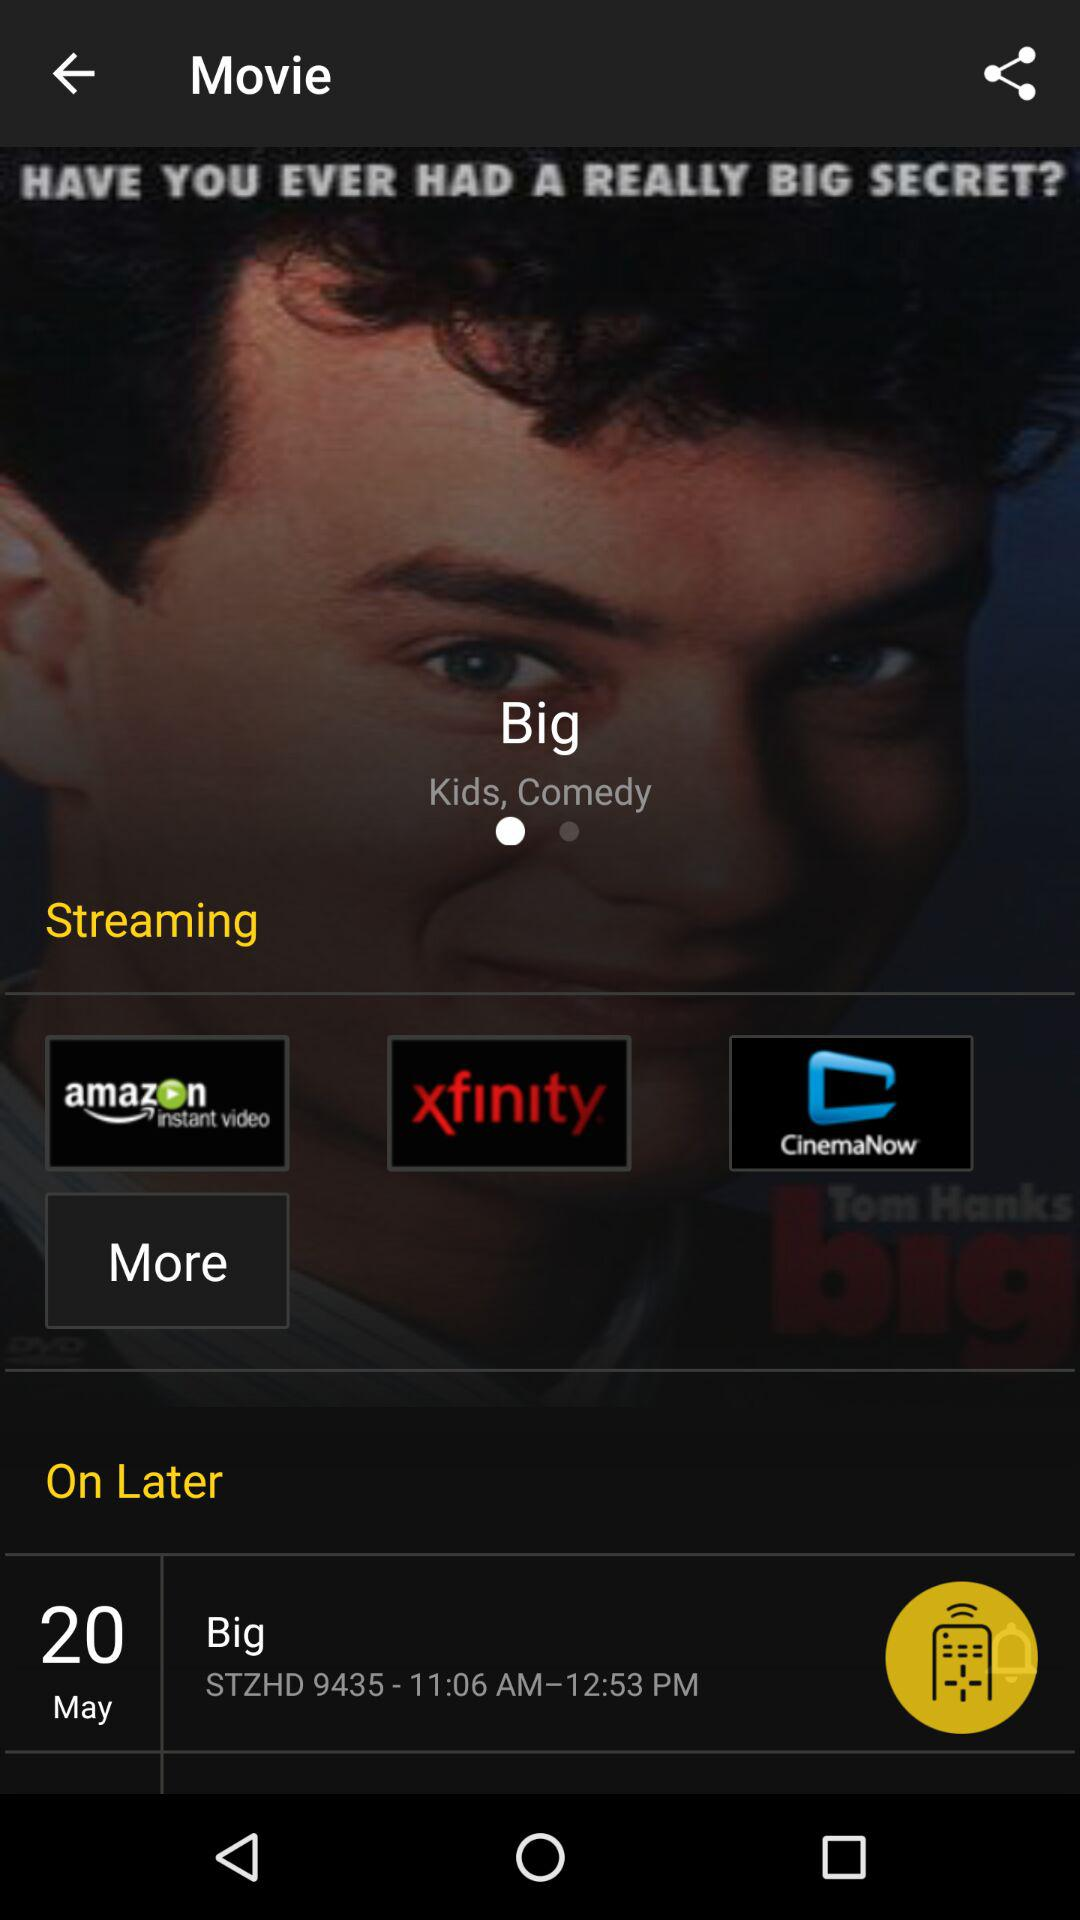What applications can I use for streaming? You can use "amazon instant video", "xfinity" and "CinemaNow". 